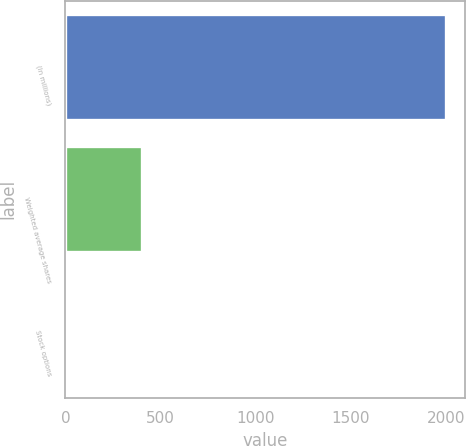<chart> <loc_0><loc_0><loc_500><loc_500><bar_chart><fcel>(In millions)<fcel>Weighted average shares<fcel>Stock options<nl><fcel>2002<fcel>402.24<fcel>2.3<nl></chart> 